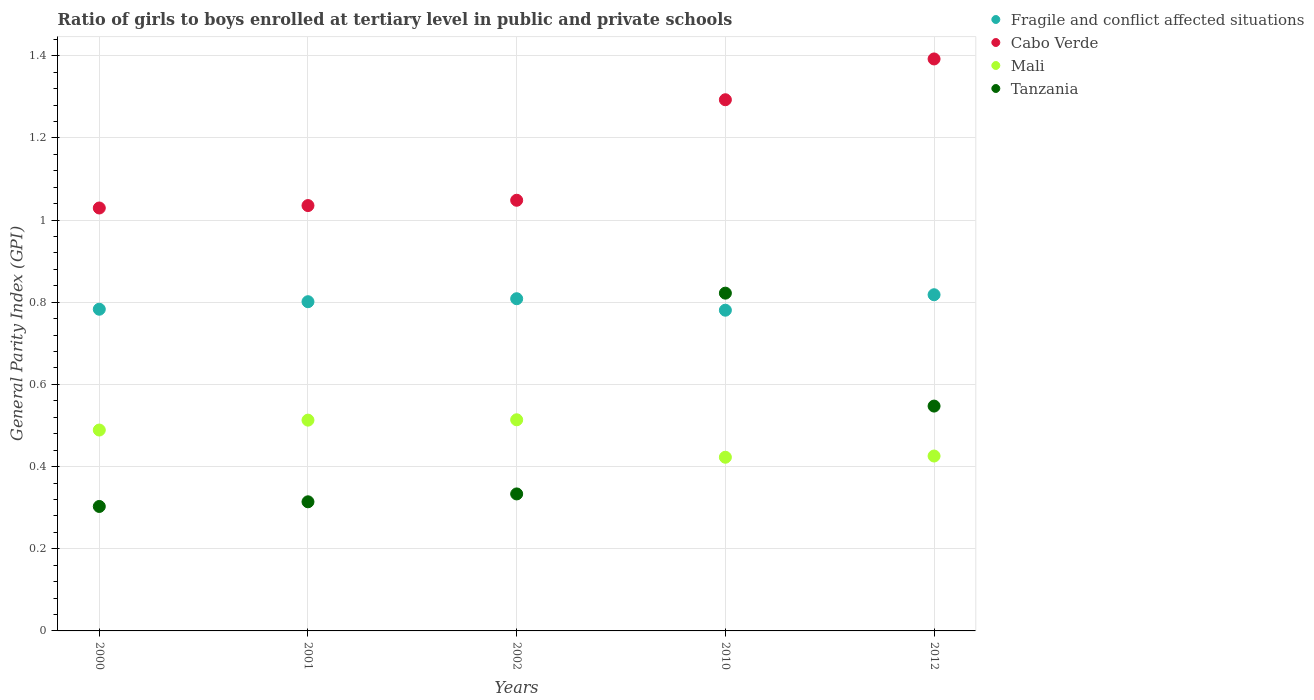What is the general parity index in Cabo Verde in 2012?
Offer a terse response. 1.39. Across all years, what is the maximum general parity index in Cabo Verde?
Offer a very short reply. 1.39. Across all years, what is the minimum general parity index in Tanzania?
Your answer should be compact. 0.3. In which year was the general parity index in Mali maximum?
Offer a very short reply. 2002. In which year was the general parity index in Fragile and conflict affected situations minimum?
Provide a succinct answer. 2010. What is the total general parity index in Mali in the graph?
Your answer should be very brief. 2.36. What is the difference between the general parity index in Cabo Verde in 2000 and that in 2001?
Your answer should be very brief. -0.01. What is the difference between the general parity index in Mali in 2010 and the general parity index in Tanzania in 2012?
Give a very brief answer. -0.12. What is the average general parity index in Mali per year?
Provide a succinct answer. 0.47. In the year 2000, what is the difference between the general parity index in Fragile and conflict affected situations and general parity index in Tanzania?
Provide a succinct answer. 0.48. What is the ratio of the general parity index in Cabo Verde in 2001 to that in 2010?
Give a very brief answer. 0.8. What is the difference between the highest and the second highest general parity index in Fragile and conflict affected situations?
Make the answer very short. 0.01. What is the difference between the highest and the lowest general parity index in Mali?
Ensure brevity in your answer.  0.09. Is the sum of the general parity index in Mali in 2002 and 2012 greater than the maximum general parity index in Fragile and conflict affected situations across all years?
Make the answer very short. Yes. What is the difference between two consecutive major ticks on the Y-axis?
Your answer should be very brief. 0.2. Where does the legend appear in the graph?
Make the answer very short. Top right. How many legend labels are there?
Give a very brief answer. 4. How are the legend labels stacked?
Make the answer very short. Vertical. What is the title of the graph?
Your answer should be compact. Ratio of girls to boys enrolled at tertiary level in public and private schools. Does "Cayman Islands" appear as one of the legend labels in the graph?
Your response must be concise. No. What is the label or title of the Y-axis?
Your answer should be very brief. General Parity Index (GPI). What is the General Parity Index (GPI) in Fragile and conflict affected situations in 2000?
Give a very brief answer. 0.78. What is the General Parity Index (GPI) of Cabo Verde in 2000?
Your response must be concise. 1.03. What is the General Parity Index (GPI) in Mali in 2000?
Your answer should be compact. 0.49. What is the General Parity Index (GPI) in Tanzania in 2000?
Ensure brevity in your answer.  0.3. What is the General Parity Index (GPI) of Fragile and conflict affected situations in 2001?
Give a very brief answer. 0.8. What is the General Parity Index (GPI) in Cabo Verde in 2001?
Ensure brevity in your answer.  1.04. What is the General Parity Index (GPI) in Mali in 2001?
Your answer should be very brief. 0.51. What is the General Parity Index (GPI) in Tanzania in 2001?
Give a very brief answer. 0.31. What is the General Parity Index (GPI) in Fragile and conflict affected situations in 2002?
Provide a short and direct response. 0.81. What is the General Parity Index (GPI) of Cabo Verde in 2002?
Your answer should be compact. 1.05. What is the General Parity Index (GPI) in Mali in 2002?
Your answer should be very brief. 0.51. What is the General Parity Index (GPI) in Tanzania in 2002?
Your answer should be very brief. 0.33. What is the General Parity Index (GPI) of Fragile and conflict affected situations in 2010?
Your answer should be very brief. 0.78. What is the General Parity Index (GPI) of Cabo Verde in 2010?
Provide a short and direct response. 1.29. What is the General Parity Index (GPI) of Mali in 2010?
Your answer should be compact. 0.42. What is the General Parity Index (GPI) of Tanzania in 2010?
Your answer should be very brief. 0.82. What is the General Parity Index (GPI) of Fragile and conflict affected situations in 2012?
Ensure brevity in your answer.  0.82. What is the General Parity Index (GPI) of Cabo Verde in 2012?
Your response must be concise. 1.39. What is the General Parity Index (GPI) in Mali in 2012?
Provide a succinct answer. 0.43. What is the General Parity Index (GPI) of Tanzania in 2012?
Offer a very short reply. 0.55. Across all years, what is the maximum General Parity Index (GPI) in Fragile and conflict affected situations?
Make the answer very short. 0.82. Across all years, what is the maximum General Parity Index (GPI) in Cabo Verde?
Make the answer very short. 1.39. Across all years, what is the maximum General Parity Index (GPI) in Mali?
Give a very brief answer. 0.51. Across all years, what is the maximum General Parity Index (GPI) of Tanzania?
Make the answer very short. 0.82. Across all years, what is the minimum General Parity Index (GPI) in Fragile and conflict affected situations?
Provide a succinct answer. 0.78. Across all years, what is the minimum General Parity Index (GPI) of Cabo Verde?
Your response must be concise. 1.03. Across all years, what is the minimum General Parity Index (GPI) of Mali?
Provide a succinct answer. 0.42. Across all years, what is the minimum General Parity Index (GPI) of Tanzania?
Provide a succinct answer. 0.3. What is the total General Parity Index (GPI) of Fragile and conflict affected situations in the graph?
Offer a terse response. 3.99. What is the total General Parity Index (GPI) in Cabo Verde in the graph?
Provide a short and direct response. 5.8. What is the total General Parity Index (GPI) of Mali in the graph?
Offer a terse response. 2.36. What is the total General Parity Index (GPI) in Tanzania in the graph?
Ensure brevity in your answer.  2.32. What is the difference between the General Parity Index (GPI) of Fragile and conflict affected situations in 2000 and that in 2001?
Your answer should be very brief. -0.02. What is the difference between the General Parity Index (GPI) of Cabo Verde in 2000 and that in 2001?
Your response must be concise. -0.01. What is the difference between the General Parity Index (GPI) in Mali in 2000 and that in 2001?
Provide a short and direct response. -0.02. What is the difference between the General Parity Index (GPI) in Tanzania in 2000 and that in 2001?
Your answer should be very brief. -0.01. What is the difference between the General Parity Index (GPI) of Fragile and conflict affected situations in 2000 and that in 2002?
Ensure brevity in your answer.  -0.03. What is the difference between the General Parity Index (GPI) of Cabo Verde in 2000 and that in 2002?
Give a very brief answer. -0.02. What is the difference between the General Parity Index (GPI) in Mali in 2000 and that in 2002?
Provide a short and direct response. -0.02. What is the difference between the General Parity Index (GPI) in Tanzania in 2000 and that in 2002?
Keep it short and to the point. -0.03. What is the difference between the General Parity Index (GPI) of Fragile and conflict affected situations in 2000 and that in 2010?
Your response must be concise. 0. What is the difference between the General Parity Index (GPI) in Cabo Verde in 2000 and that in 2010?
Offer a terse response. -0.26. What is the difference between the General Parity Index (GPI) in Mali in 2000 and that in 2010?
Ensure brevity in your answer.  0.07. What is the difference between the General Parity Index (GPI) in Tanzania in 2000 and that in 2010?
Keep it short and to the point. -0.52. What is the difference between the General Parity Index (GPI) in Fragile and conflict affected situations in 2000 and that in 2012?
Offer a very short reply. -0.04. What is the difference between the General Parity Index (GPI) in Cabo Verde in 2000 and that in 2012?
Provide a succinct answer. -0.36. What is the difference between the General Parity Index (GPI) in Mali in 2000 and that in 2012?
Offer a very short reply. 0.06. What is the difference between the General Parity Index (GPI) of Tanzania in 2000 and that in 2012?
Keep it short and to the point. -0.24. What is the difference between the General Parity Index (GPI) of Fragile and conflict affected situations in 2001 and that in 2002?
Your response must be concise. -0.01. What is the difference between the General Parity Index (GPI) of Cabo Verde in 2001 and that in 2002?
Your answer should be very brief. -0.01. What is the difference between the General Parity Index (GPI) in Mali in 2001 and that in 2002?
Offer a very short reply. -0. What is the difference between the General Parity Index (GPI) in Tanzania in 2001 and that in 2002?
Ensure brevity in your answer.  -0.02. What is the difference between the General Parity Index (GPI) in Fragile and conflict affected situations in 2001 and that in 2010?
Ensure brevity in your answer.  0.02. What is the difference between the General Parity Index (GPI) of Cabo Verde in 2001 and that in 2010?
Offer a terse response. -0.26. What is the difference between the General Parity Index (GPI) in Mali in 2001 and that in 2010?
Provide a short and direct response. 0.09. What is the difference between the General Parity Index (GPI) in Tanzania in 2001 and that in 2010?
Give a very brief answer. -0.51. What is the difference between the General Parity Index (GPI) of Fragile and conflict affected situations in 2001 and that in 2012?
Offer a terse response. -0.02. What is the difference between the General Parity Index (GPI) of Cabo Verde in 2001 and that in 2012?
Keep it short and to the point. -0.36. What is the difference between the General Parity Index (GPI) of Mali in 2001 and that in 2012?
Your response must be concise. 0.09. What is the difference between the General Parity Index (GPI) of Tanzania in 2001 and that in 2012?
Keep it short and to the point. -0.23. What is the difference between the General Parity Index (GPI) in Fragile and conflict affected situations in 2002 and that in 2010?
Make the answer very short. 0.03. What is the difference between the General Parity Index (GPI) in Cabo Verde in 2002 and that in 2010?
Make the answer very short. -0.24. What is the difference between the General Parity Index (GPI) of Mali in 2002 and that in 2010?
Make the answer very short. 0.09. What is the difference between the General Parity Index (GPI) of Tanzania in 2002 and that in 2010?
Keep it short and to the point. -0.49. What is the difference between the General Parity Index (GPI) of Fragile and conflict affected situations in 2002 and that in 2012?
Your answer should be compact. -0.01. What is the difference between the General Parity Index (GPI) in Cabo Verde in 2002 and that in 2012?
Provide a short and direct response. -0.34. What is the difference between the General Parity Index (GPI) in Mali in 2002 and that in 2012?
Keep it short and to the point. 0.09. What is the difference between the General Parity Index (GPI) in Tanzania in 2002 and that in 2012?
Make the answer very short. -0.21. What is the difference between the General Parity Index (GPI) in Fragile and conflict affected situations in 2010 and that in 2012?
Offer a terse response. -0.04. What is the difference between the General Parity Index (GPI) of Cabo Verde in 2010 and that in 2012?
Your answer should be compact. -0.1. What is the difference between the General Parity Index (GPI) of Mali in 2010 and that in 2012?
Offer a very short reply. -0. What is the difference between the General Parity Index (GPI) in Tanzania in 2010 and that in 2012?
Your answer should be compact. 0.27. What is the difference between the General Parity Index (GPI) in Fragile and conflict affected situations in 2000 and the General Parity Index (GPI) in Cabo Verde in 2001?
Your answer should be very brief. -0.25. What is the difference between the General Parity Index (GPI) in Fragile and conflict affected situations in 2000 and the General Parity Index (GPI) in Mali in 2001?
Offer a very short reply. 0.27. What is the difference between the General Parity Index (GPI) in Fragile and conflict affected situations in 2000 and the General Parity Index (GPI) in Tanzania in 2001?
Your answer should be compact. 0.47. What is the difference between the General Parity Index (GPI) of Cabo Verde in 2000 and the General Parity Index (GPI) of Mali in 2001?
Your response must be concise. 0.52. What is the difference between the General Parity Index (GPI) in Cabo Verde in 2000 and the General Parity Index (GPI) in Tanzania in 2001?
Your response must be concise. 0.72. What is the difference between the General Parity Index (GPI) of Mali in 2000 and the General Parity Index (GPI) of Tanzania in 2001?
Your answer should be compact. 0.17. What is the difference between the General Parity Index (GPI) in Fragile and conflict affected situations in 2000 and the General Parity Index (GPI) in Cabo Verde in 2002?
Offer a terse response. -0.27. What is the difference between the General Parity Index (GPI) in Fragile and conflict affected situations in 2000 and the General Parity Index (GPI) in Mali in 2002?
Provide a succinct answer. 0.27. What is the difference between the General Parity Index (GPI) in Fragile and conflict affected situations in 2000 and the General Parity Index (GPI) in Tanzania in 2002?
Your answer should be very brief. 0.45. What is the difference between the General Parity Index (GPI) in Cabo Verde in 2000 and the General Parity Index (GPI) in Mali in 2002?
Keep it short and to the point. 0.52. What is the difference between the General Parity Index (GPI) of Cabo Verde in 2000 and the General Parity Index (GPI) of Tanzania in 2002?
Give a very brief answer. 0.7. What is the difference between the General Parity Index (GPI) of Mali in 2000 and the General Parity Index (GPI) of Tanzania in 2002?
Offer a terse response. 0.16. What is the difference between the General Parity Index (GPI) in Fragile and conflict affected situations in 2000 and the General Parity Index (GPI) in Cabo Verde in 2010?
Your answer should be very brief. -0.51. What is the difference between the General Parity Index (GPI) of Fragile and conflict affected situations in 2000 and the General Parity Index (GPI) of Mali in 2010?
Provide a succinct answer. 0.36. What is the difference between the General Parity Index (GPI) of Fragile and conflict affected situations in 2000 and the General Parity Index (GPI) of Tanzania in 2010?
Keep it short and to the point. -0.04. What is the difference between the General Parity Index (GPI) in Cabo Verde in 2000 and the General Parity Index (GPI) in Mali in 2010?
Offer a terse response. 0.61. What is the difference between the General Parity Index (GPI) of Cabo Verde in 2000 and the General Parity Index (GPI) of Tanzania in 2010?
Offer a very short reply. 0.21. What is the difference between the General Parity Index (GPI) in Mali in 2000 and the General Parity Index (GPI) in Tanzania in 2010?
Provide a succinct answer. -0.33. What is the difference between the General Parity Index (GPI) of Fragile and conflict affected situations in 2000 and the General Parity Index (GPI) of Cabo Verde in 2012?
Provide a short and direct response. -0.61. What is the difference between the General Parity Index (GPI) in Fragile and conflict affected situations in 2000 and the General Parity Index (GPI) in Mali in 2012?
Your answer should be very brief. 0.36. What is the difference between the General Parity Index (GPI) in Fragile and conflict affected situations in 2000 and the General Parity Index (GPI) in Tanzania in 2012?
Keep it short and to the point. 0.24. What is the difference between the General Parity Index (GPI) of Cabo Verde in 2000 and the General Parity Index (GPI) of Mali in 2012?
Offer a terse response. 0.6. What is the difference between the General Parity Index (GPI) in Cabo Verde in 2000 and the General Parity Index (GPI) in Tanzania in 2012?
Offer a terse response. 0.48. What is the difference between the General Parity Index (GPI) of Mali in 2000 and the General Parity Index (GPI) of Tanzania in 2012?
Your answer should be compact. -0.06. What is the difference between the General Parity Index (GPI) of Fragile and conflict affected situations in 2001 and the General Parity Index (GPI) of Cabo Verde in 2002?
Keep it short and to the point. -0.25. What is the difference between the General Parity Index (GPI) in Fragile and conflict affected situations in 2001 and the General Parity Index (GPI) in Mali in 2002?
Your answer should be compact. 0.29. What is the difference between the General Parity Index (GPI) of Fragile and conflict affected situations in 2001 and the General Parity Index (GPI) of Tanzania in 2002?
Your answer should be very brief. 0.47. What is the difference between the General Parity Index (GPI) in Cabo Verde in 2001 and the General Parity Index (GPI) in Mali in 2002?
Ensure brevity in your answer.  0.52. What is the difference between the General Parity Index (GPI) of Cabo Verde in 2001 and the General Parity Index (GPI) of Tanzania in 2002?
Your answer should be very brief. 0.7. What is the difference between the General Parity Index (GPI) of Mali in 2001 and the General Parity Index (GPI) of Tanzania in 2002?
Your answer should be very brief. 0.18. What is the difference between the General Parity Index (GPI) in Fragile and conflict affected situations in 2001 and the General Parity Index (GPI) in Cabo Verde in 2010?
Ensure brevity in your answer.  -0.49. What is the difference between the General Parity Index (GPI) in Fragile and conflict affected situations in 2001 and the General Parity Index (GPI) in Mali in 2010?
Provide a succinct answer. 0.38. What is the difference between the General Parity Index (GPI) in Fragile and conflict affected situations in 2001 and the General Parity Index (GPI) in Tanzania in 2010?
Your answer should be very brief. -0.02. What is the difference between the General Parity Index (GPI) in Cabo Verde in 2001 and the General Parity Index (GPI) in Mali in 2010?
Ensure brevity in your answer.  0.61. What is the difference between the General Parity Index (GPI) in Cabo Verde in 2001 and the General Parity Index (GPI) in Tanzania in 2010?
Your answer should be very brief. 0.21. What is the difference between the General Parity Index (GPI) in Mali in 2001 and the General Parity Index (GPI) in Tanzania in 2010?
Make the answer very short. -0.31. What is the difference between the General Parity Index (GPI) in Fragile and conflict affected situations in 2001 and the General Parity Index (GPI) in Cabo Verde in 2012?
Ensure brevity in your answer.  -0.59. What is the difference between the General Parity Index (GPI) of Fragile and conflict affected situations in 2001 and the General Parity Index (GPI) of Mali in 2012?
Provide a succinct answer. 0.38. What is the difference between the General Parity Index (GPI) of Fragile and conflict affected situations in 2001 and the General Parity Index (GPI) of Tanzania in 2012?
Provide a short and direct response. 0.25. What is the difference between the General Parity Index (GPI) in Cabo Verde in 2001 and the General Parity Index (GPI) in Mali in 2012?
Your answer should be very brief. 0.61. What is the difference between the General Parity Index (GPI) in Cabo Verde in 2001 and the General Parity Index (GPI) in Tanzania in 2012?
Your answer should be compact. 0.49. What is the difference between the General Parity Index (GPI) in Mali in 2001 and the General Parity Index (GPI) in Tanzania in 2012?
Offer a terse response. -0.03. What is the difference between the General Parity Index (GPI) in Fragile and conflict affected situations in 2002 and the General Parity Index (GPI) in Cabo Verde in 2010?
Offer a terse response. -0.48. What is the difference between the General Parity Index (GPI) of Fragile and conflict affected situations in 2002 and the General Parity Index (GPI) of Mali in 2010?
Keep it short and to the point. 0.39. What is the difference between the General Parity Index (GPI) in Fragile and conflict affected situations in 2002 and the General Parity Index (GPI) in Tanzania in 2010?
Give a very brief answer. -0.01. What is the difference between the General Parity Index (GPI) in Cabo Verde in 2002 and the General Parity Index (GPI) in Mali in 2010?
Your answer should be very brief. 0.63. What is the difference between the General Parity Index (GPI) in Cabo Verde in 2002 and the General Parity Index (GPI) in Tanzania in 2010?
Your answer should be compact. 0.23. What is the difference between the General Parity Index (GPI) in Mali in 2002 and the General Parity Index (GPI) in Tanzania in 2010?
Offer a terse response. -0.31. What is the difference between the General Parity Index (GPI) of Fragile and conflict affected situations in 2002 and the General Parity Index (GPI) of Cabo Verde in 2012?
Ensure brevity in your answer.  -0.58. What is the difference between the General Parity Index (GPI) in Fragile and conflict affected situations in 2002 and the General Parity Index (GPI) in Mali in 2012?
Offer a terse response. 0.38. What is the difference between the General Parity Index (GPI) of Fragile and conflict affected situations in 2002 and the General Parity Index (GPI) of Tanzania in 2012?
Offer a terse response. 0.26. What is the difference between the General Parity Index (GPI) in Cabo Verde in 2002 and the General Parity Index (GPI) in Mali in 2012?
Give a very brief answer. 0.62. What is the difference between the General Parity Index (GPI) in Cabo Verde in 2002 and the General Parity Index (GPI) in Tanzania in 2012?
Ensure brevity in your answer.  0.5. What is the difference between the General Parity Index (GPI) of Mali in 2002 and the General Parity Index (GPI) of Tanzania in 2012?
Provide a succinct answer. -0.03. What is the difference between the General Parity Index (GPI) of Fragile and conflict affected situations in 2010 and the General Parity Index (GPI) of Cabo Verde in 2012?
Make the answer very short. -0.61. What is the difference between the General Parity Index (GPI) in Fragile and conflict affected situations in 2010 and the General Parity Index (GPI) in Mali in 2012?
Your answer should be very brief. 0.35. What is the difference between the General Parity Index (GPI) in Fragile and conflict affected situations in 2010 and the General Parity Index (GPI) in Tanzania in 2012?
Your response must be concise. 0.23. What is the difference between the General Parity Index (GPI) of Cabo Verde in 2010 and the General Parity Index (GPI) of Mali in 2012?
Ensure brevity in your answer.  0.87. What is the difference between the General Parity Index (GPI) in Cabo Verde in 2010 and the General Parity Index (GPI) in Tanzania in 2012?
Keep it short and to the point. 0.75. What is the difference between the General Parity Index (GPI) in Mali in 2010 and the General Parity Index (GPI) in Tanzania in 2012?
Offer a very short reply. -0.12. What is the average General Parity Index (GPI) in Fragile and conflict affected situations per year?
Offer a terse response. 0.8. What is the average General Parity Index (GPI) in Cabo Verde per year?
Keep it short and to the point. 1.16. What is the average General Parity Index (GPI) in Mali per year?
Offer a very short reply. 0.47. What is the average General Parity Index (GPI) in Tanzania per year?
Offer a very short reply. 0.46. In the year 2000, what is the difference between the General Parity Index (GPI) in Fragile and conflict affected situations and General Parity Index (GPI) in Cabo Verde?
Give a very brief answer. -0.25. In the year 2000, what is the difference between the General Parity Index (GPI) in Fragile and conflict affected situations and General Parity Index (GPI) in Mali?
Give a very brief answer. 0.29. In the year 2000, what is the difference between the General Parity Index (GPI) in Fragile and conflict affected situations and General Parity Index (GPI) in Tanzania?
Offer a very short reply. 0.48. In the year 2000, what is the difference between the General Parity Index (GPI) in Cabo Verde and General Parity Index (GPI) in Mali?
Make the answer very short. 0.54. In the year 2000, what is the difference between the General Parity Index (GPI) of Cabo Verde and General Parity Index (GPI) of Tanzania?
Offer a very short reply. 0.73. In the year 2000, what is the difference between the General Parity Index (GPI) of Mali and General Parity Index (GPI) of Tanzania?
Give a very brief answer. 0.19. In the year 2001, what is the difference between the General Parity Index (GPI) in Fragile and conflict affected situations and General Parity Index (GPI) in Cabo Verde?
Your answer should be compact. -0.23. In the year 2001, what is the difference between the General Parity Index (GPI) in Fragile and conflict affected situations and General Parity Index (GPI) in Mali?
Your response must be concise. 0.29. In the year 2001, what is the difference between the General Parity Index (GPI) of Fragile and conflict affected situations and General Parity Index (GPI) of Tanzania?
Your answer should be compact. 0.49. In the year 2001, what is the difference between the General Parity Index (GPI) of Cabo Verde and General Parity Index (GPI) of Mali?
Ensure brevity in your answer.  0.52. In the year 2001, what is the difference between the General Parity Index (GPI) of Cabo Verde and General Parity Index (GPI) of Tanzania?
Keep it short and to the point. 0.72. In the year 2001, what is the difference between the General Parity Index (GPI) of Mali and General Parity Index (GPI) of Tanzania?
Provide a succinct answer. 0.2. In the year 2002, what is the difference between the General Parity Index (GPI) in Fragile and conflict affected situations and General Parity Index (GPI) in Cabo Verde?
Offer a very short reply. -0.24. In the year 2002, what is the difference between the General Parity Index (GPI) in Fragile and conflict affected situations and General Parity Index (GPI) in Mali?
Give a very brief answer. 0.29. In the year 2002, what is the difference between the General Parity Index (GPI) of Fragile and conflict affected situations and General Parity Index (GPI) of Tanzania?
Give a very brief answer. 0.48. In the year 2002, what is the difference between the General Parity Index (GPI) in Cabo Verde and General Parity Index (GPI) in Mali?
Offer a very short reply. 0.53. In the year 2002, what is the difference between the General Parity Index (GPI) of Cabo Verde and General Parity Index (GPI) of Tanzania?
Your response must be concise. 0.71. In the year 2002, what is the difference between the General Parity Index (GPI) in Mali and General Parity Index (GPI) in Tanzania?
Give a very brief answer. 0.18. In the year 2010, what is the difference between the General Parity Index (GPI) in Fragile and conflict affected situations and General Parity Index (GPI) in Cabo Verde?
Make the answer very short. -0.51. In the year 2010, what is the difference between the General Parity Index (GPI) of Fragile and conflict affected situations and General Parity Index (GPI) of Mali?
Offer a very short reply. 0.36. In the year 2010, what is the difference between the General Parity Index (GPI) in Fragile and conflict affected situations and General Parity Index (GPI) in Tanzania?
Ensure brevity in your answer.  -0.04. In the year 2010, what is the difference between the General Parity Index (GPI) of Cabo Verde and General Parity Index (GPI) of Mali?
Provide a short and direct response. 0.87. In the year 2010, what is the difference between the General Parity Index (GPI) of Cabo Verde and General Parity Index (GPI) of Tanzania?
Provide a short and direct response. 0.47. In the year 2010, what is the difference between the General Parity Index (GPI) in Mali and General Parity Index (GPI) in Tanzania?
Ensure brevity in your answer.  -0.4. In the year 2012, what is the difference between the General Parity Index (GPI) in Fragile and conflict affected situations and General Parity Index (GPI) in Cabo Verde?
Your answer should be very brief. -0.57. In the year 2012, what is the difference between the General Parity Index (GPI) in Fragile and conflict affected situations and General Parity Index (GPI) in Mali?
Ensure brevity in your answer.  0.39. In the year 2012, what is the difference between the General Parity Index (GPI) in Fragile and conflict affected situations and General Parity Index (GPI) in Tanzania?
Offer a terse response. 0.27. In the year 2012, what is the difference between the General Parity Index (GPI) in Cabo Verde and General Parity Index (GPI) in Mali?
Keep it short and to the point. 0.97. In the year 2012, what is the difference between the General Parity Index (GPI) of Cabo Verde and General Parity Index (GPI) of Tanzania?
Provide a succinct answer. 0.84. In the year 2012, what is the difference between the General Parity Index (GPI) in Mali and General Parity Index (GPI) in Tanzania?
Offer a terse response. -0.12. What is the ratio of the General Parity Index (GPI) in Fragile and conflict affected situations in 2000 to that in 2001?
Offer a terse response. 0.98. What is the ratio of the General Parity Index (GPI) in Cabo Verde in 2000 to that in 2001?
Make the answer very short. 0.99. What is the ratio of the General Parity Index (GPI) in Mali in 2000 to that in 2001?
Provide a succinct answer. 0.95. What is the ratio of the General Parity Index (GPI) of Tanzania in 2000 to that in 2001?
Give a very brief answer. 0.96. What is the ratio of the General Parity Index (GPI) of Fragile and conflict affected situations in 2000 to that in 2002?
Your response must be concise. 0.97. What is the ratio of the General Parity Index (GPI) of Cabo Verde in 2000 to that in 2002?
Your answer should be compact. 0.98. What is the ratio of the General Parity Index (GPI) in Mali in 2000 to that in 2002?
Offer a very short reply. 0.95. What is the ratio of the General Parity Index (GPI) in Tanzania in 2000 to that in 2002?
Offer a terse response. 0.91. What is the ratio of the General Parity Index (GPI) in Fragile and conflict affected situations in 2000 to that in 2010?
Your answer should be compact. 1. What is the ratio of the General Parity Index (GPI) in Cabo Verde in 2000 to that in 2010?
Your answer should be compact. 0.8. What is the ratio of the General Parity Index (GPI) in Mali in 2000 to that in 2010?
Your answer should be very brief. 1.16. What is the ratio of the General Parity Index (GPI) of Tanzania in 2000 to that in 2010?
Your answer should be compact. 0.37. What is the ratio of the General Parity Index (GPI) of Fragile and conflict affected situations in 2000 to that in 2012?
Your answer should be very brief. 0.96. What is the ratio of the General Parity Index (GPI) of Cabo Verde in 2000 to that in 2012?
Offer a very short reply. 0.74. What is the ratio of the General Parity Index (GPI) of Mali in 2000 to that in 2012?
Make the answer very short. 1.15. What is the ratio of the General Parity Index (GPI) of Tanzania in 2000 to that in 2012?
Your response must be concise. 0.55. What is the ratio of the General Parity Index (GPI) of Fragile and conflict affected situations in 2001 to that in 2002?
Offer a very short reply. 0.99. What is the ratio of the General Parity Index (GPI) in Mali in 2001 to that in 2002?
Keep it short and to the point. 1. What is the ratio of the General Parity Index (GPI) of Tanzania in 2001 to that in 2002?
Offer a terse response. 0.94. What is the ratio of the General Parity Index (GPI) in Fragile and conflict affected situations in 2001 to that in 2010?
Make the answer very short. 1.03. What is the ratio of the General Parity Index (GPI) of Cabo Verde in 2001 to that in 2010?
Give a very brief answer. 0.8. What is the ratio of the General Parity Index (GPI) in Mali in 2001 to that in 2010?
Offer a terse response. 1.21. What is the ratio of the General Parity Index (GPI) of Tanzania in 2001 to that in 2010?
Your answer should be very brief. 0.38. What is the ratio of the General Parity Index (GPI) of Fragile and conflict affected situations in 2001 to that in 2012?
Provide a short and direct response. 0.98. What is the ratio of the General Parity Index (GPI) in Cabo Verde in 2001 to that in 2012?
Offer a terse response. 0.74. What is the ratio of the General Parity Index (GPI) of Mali in 2001 to that in 2012?
Give a very brief answer. 1.21. What is the ratio of the General Parity Index (GPI) in Tanzania in 2001 to that in 2012?
Your response must be concise. 0.57. What is the ratio of the General Parity Index (GPI) of Fragile and conflict affected situations in 2002 to that in 2010?
Offer a very short reply. 1.04. What is the ratio of the General Parity Index (GPI) of Cabo Verde in 2002 to that in 2010?
Offer a terse response. 0.81. What is the ratio of the General Parity Index (GPI) in Mali in 2002 to that in 2010?
Ensure brevity in your answer.  1.22. What is the ratio of the General Parity Index (GPI) in Tanzania in 2002 to that in 2010?
Make the answer very short. 0.41. What is the ratio of the General Parity Index (GPI) in Fragile and conflict affected situations in 2002 to that in 2012?
Provide a succinct answer. 0.99. What is the ratio of the General Parity Index (GPI) in Cabo Verde in 2002 to that in 2012?
Provide a succinct answer. 0.75. What is the ratio of the General Parity Index (GPI) of Mali in 2002 to that in 2012?
Offer a very short reply. 1.21. What is the ratio of the General Parity Index (GPI) of Tanzania in 2002 to that in 2012?
Provide a short and direct response. 0.61. What is the ratio of the General Parity Index (GPI) of Fragile and conflict affected situations in 2010 to that in 2012?
Give a very brief answer. 0.95. What is the ratio of the General Parity Index (GPI) in Cabo Verde in 2010 to that in 2012?
Ensure brevity in your answer.  0.93. What is the ratio of the General Parity Index (GPI) of Tanzania in 2010 to that in 2012?
Make the answer very short. 1.5. What is the difference between the highest and the second highest General Parity Index (GPI) in Fragile and conflict affected situations?
Keep it short and to the point. 0.01. What is the difference between the highest and the second highest General Parity Index (GPI) in Cabo Verde?
Provide a short and direct response. 0.1. What is the difference between the highest and the second highest General Parity Index (GPI) of Mali?
Your answer should be very brief. 0. What is the difference between the highest and the second highest General Parity Index (GPI) in Tanzania?
Give a very brief answer. 0.27. What is the difference between the highest and the lowest General Parity Index (GPI) in Fragile and conflict affected situations?
Your answer should be compact. 0.04. What is the difference between the highest and the lowest General Parity Index (GPI) in Cabo Verde?
Offer a terse response. 0.36. What is the difference between the highest and the lowest General Parity Index (GPI) in Mali?
Your answer should be compact. 0.09. What is the difference between the highest and the lowest General Parity Index (GPI) in Tanzania?
Provide a succinct answer. 0.52. 